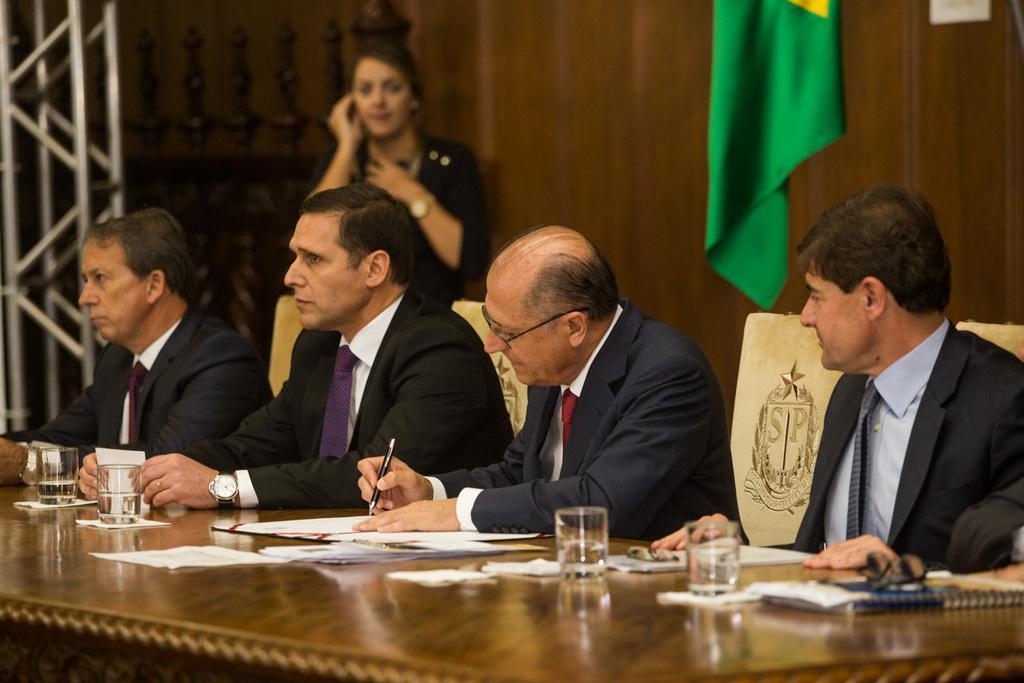Could you give a brief overview of what you see in this image? This picture is clicked inside. In the foreground there is a table on the top of which book, papers, glasses of water and some other items are placed. On the right there is a person wearing suit and sitting on the chair. In the center there is a man wearing suit, sitting on the chair, holding a pen and seems to be writing something on the paper. On the left we can see the two persons wearing suits and sitting on the chairs. In the background we can see the metal rods, flag and a person standing on the ground and seems to be talking on a mobile phone. 